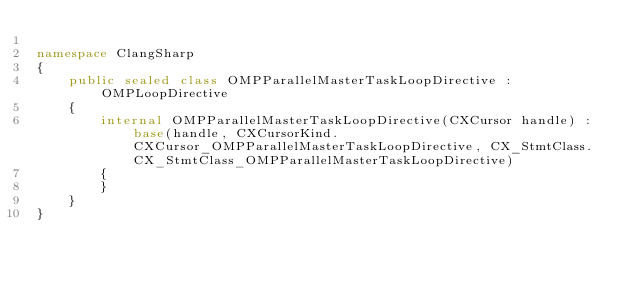<code> <loc_0><loc_0><loc_500><loc_500><_C#_>
namespace ClangSharp
{
    public sealed class OMPParallelMasterTaskLoopDirective : OMPLoopDirective
    {
        internal OMPParallelMasterTaskLoopDirective(CXCursor handle) : base(handle, CXCursorKind.CXCursor_OMPParallelMasterTaskLoopDirective, CX_StmtClass.CX_StmtClass_OMPParallelMasterTaskLoopDirective)
        {
        }
    }
}
</code> 